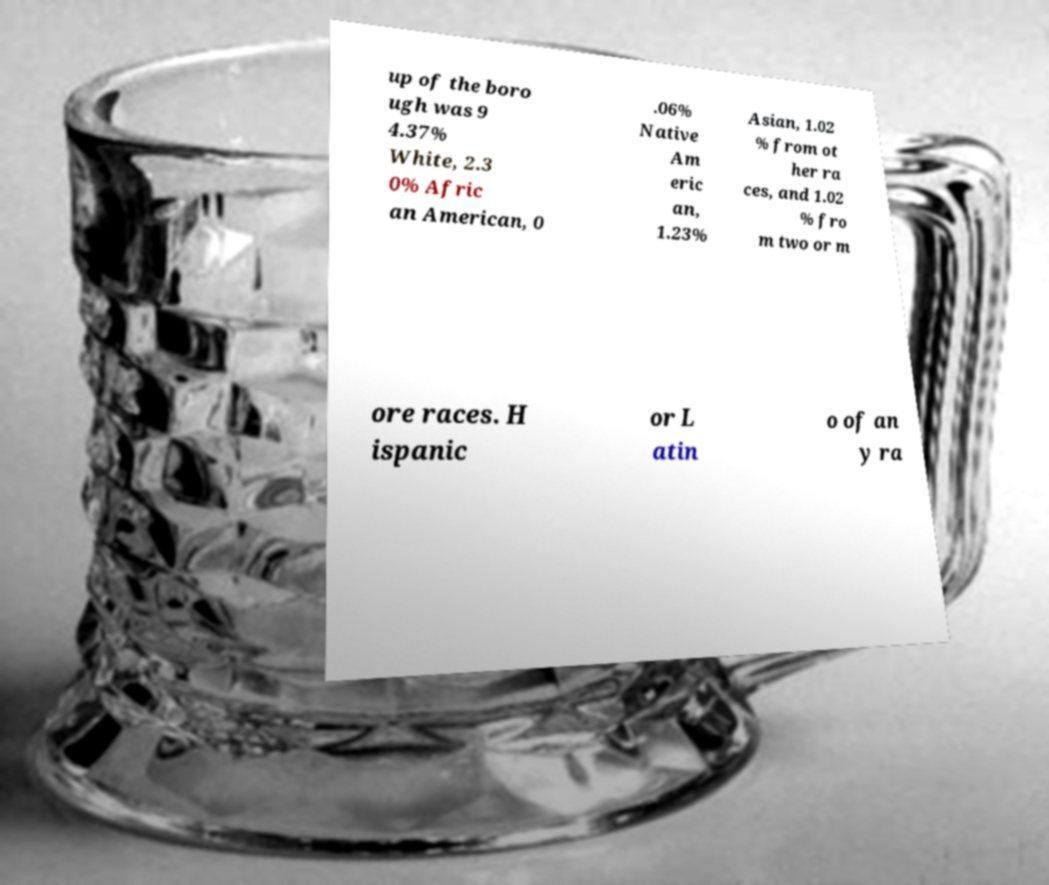Can you accurately transcribe the text from the provided image for me? up of the boro ugh was 9 4.37% White, 2.3 0% Afric an American, 0 .06% Native Am eric an, 1.23% Asian, 1.02 % from ot her ra ces, and 1.02 % fro m two or m ore races. H ispanic or L atin o of an y ra 